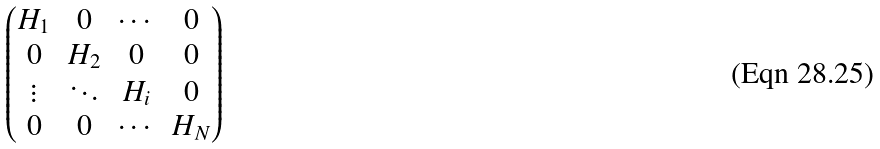Convert formula to latex. <formula><loc_0><loc_0><loc_500><loc_500>\begin{pmatrix} H _ { 1 } & 0 & \cdots & 0 \\ 0 & H _ { 2 } & 0 & 0 \\ \vdots & \ddots & H _ { i } & 0 \\ 0 & 0 & \cdots & H _ { N } \end{pmatrix}</formula> 